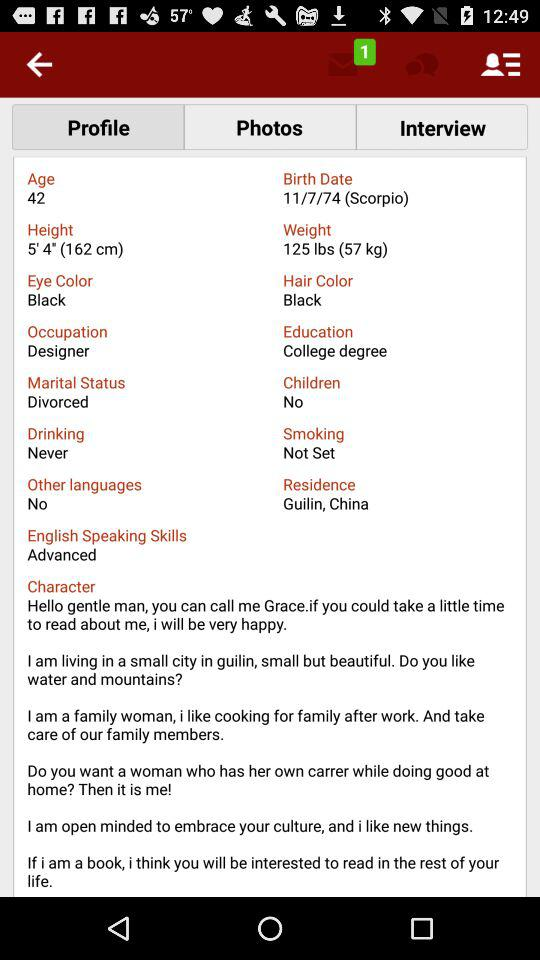Where is the residence? The residence is in Guilin, China. 